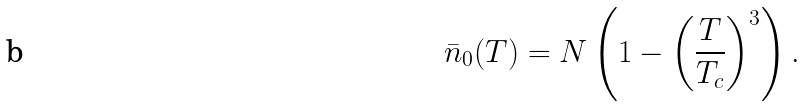<formula> <loc_0><loc_0><loc_500><loc_500>\bar { n } _ { 0 } ( T ) = N \left ( 1 - \left ( \frac { T } { T _ { c } } \right ) ^ { 3 } \right ) .</formula> 